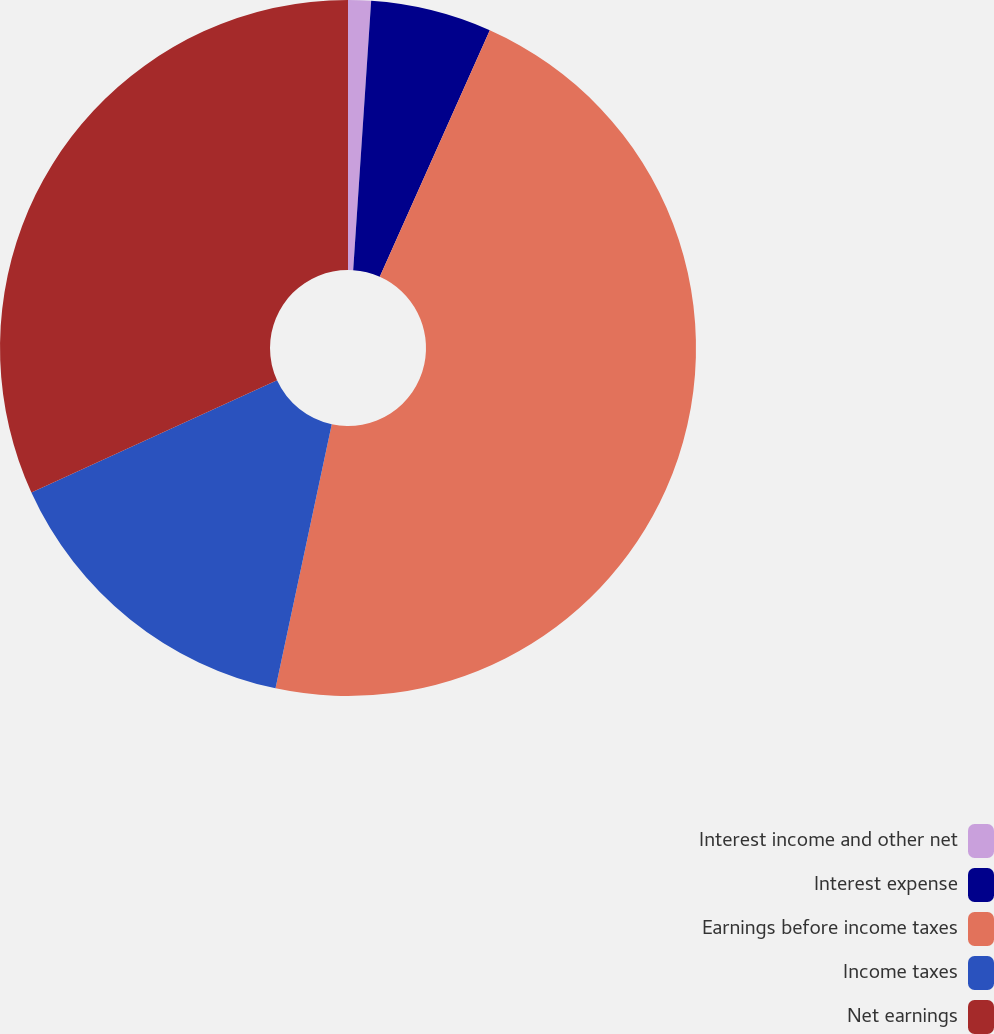<chart> <loc_0><loc_0><loc_500><loc_500><pie_chart><fcel>Interest income and other net<fcel>Interest expense<fcel>Earnings before income taxes<fcel>Income taxes<fcel>Net earnings<nl><fcel>1.06%<fcel>5.62%<fcel>46.66%<fcel>14.85%<fcel>31.81%<nl></chart> 